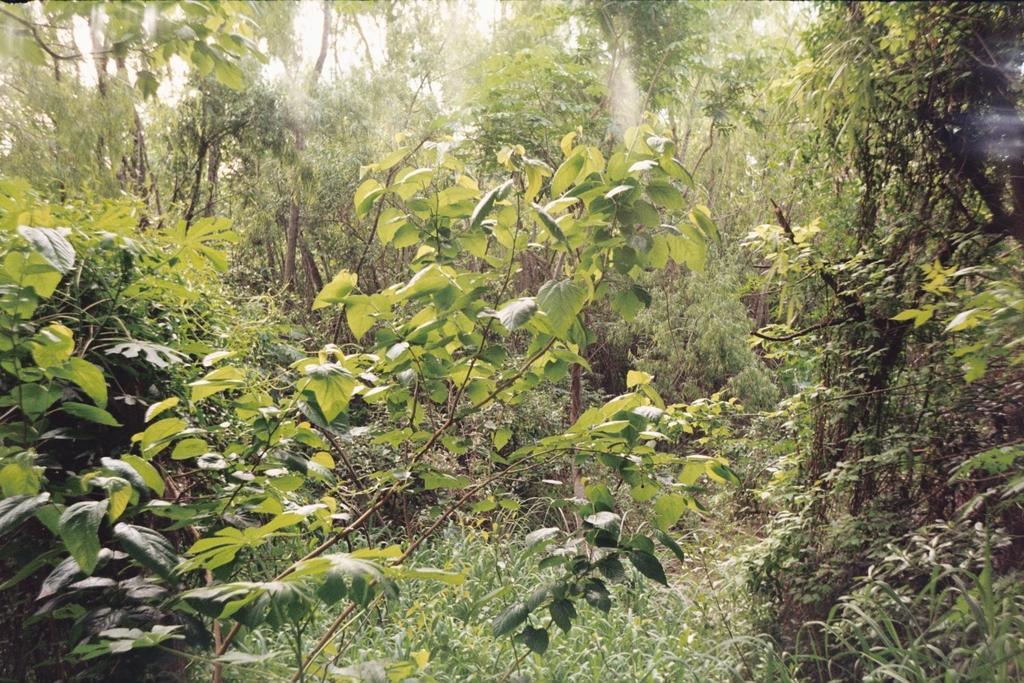What type of vegetation is present in the image? There are many trees in the image. What color are the trees in the image? The trees are green in color. What can be seen in the background of the image? The sky is visible in the background of the image. What color is the sky in the image? The sky is white in color. What type of motion can be observed in the trees in the image? There is no motion observed in the trees in the image; they are stationary. What statement is being made by the trees in the image? Trees do not make statements; they are inanimate objects. 